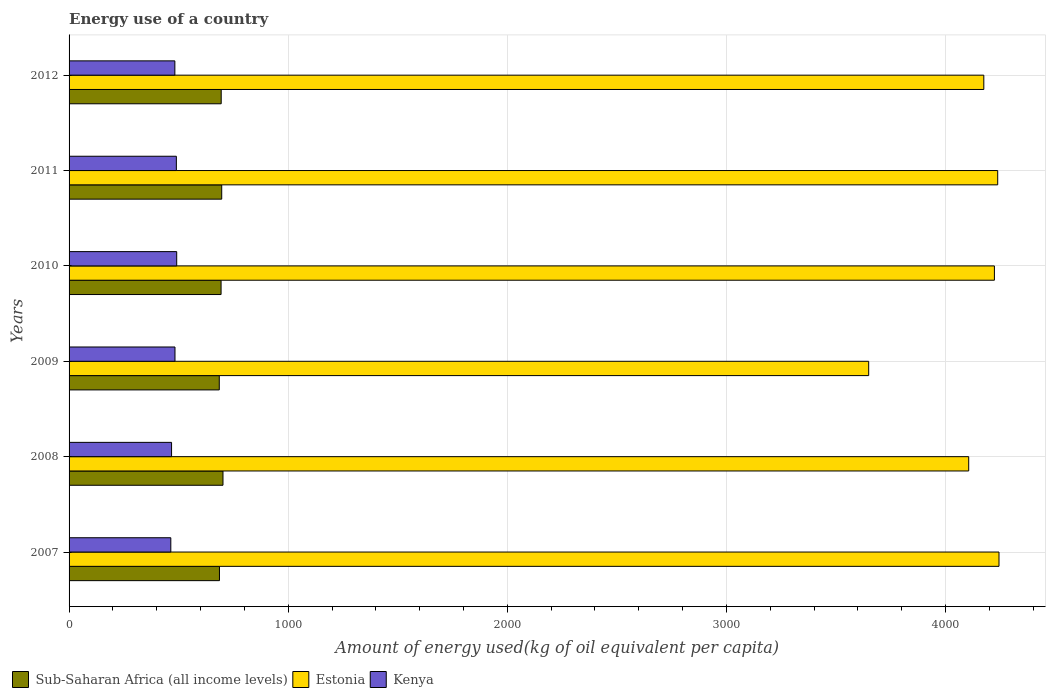How many different coloured bars are there?
Ensure brevity in your answer.  3. How many groups of bars are there?
Offer a very short reply. 6. Are the number of bars per tick equal to the number of legend labels?
Provide a succinct answer. Yes. Are the number of bars on each tick of the Y-axis equal?
Give a very brief answer. Yes. What is the amount of energy used in in Kenya in 2012?
Give a very brief answer. 482.79. Across all years, what is the maximum amount of energy used in in Estonia?
Offer a terse response. 4243.65. Across all years, what is the minimum amount of energy used in in Estonia?
Your response must be concise. 3648.98. What is the total amount of energy used in in Sub-Saharan Africa (all income levels) in the graph?
Make the answer very short. 4158.66. What is the difference between the amount of energy used in in Sub-Saharan Africa (all income levels) in 2007 and that in 2008?
Offer a terse response. -16.02. What is the difference between the amount of energy used in in Estonia in 2007 and the amount of energy used in in Sub-Saharan Africa (all income levels) in 2012?
Give a very brief answer. 3549.4. What is the average amount of energy used in in Estonia per year?
Give a very brief answer. 4105.48. In the year 2012, what is the difference between the amount of energy used in in Kenya and amount of energy used in in Estonia?
Your answer should be very brief. -3691.6. In how many years, is the amount of energy used in in Sub-Saharan Africa (all income levels) greater than 400 kg?
Your answer should be compact. 6. What is the ratio of the amount of energy used in in Kenya in 2011 to that in 2012?
Offer a very short reply. 1.01. Is the difference between the amount of energy used in in Kenya in 2007 and 2008 greater than the difference between the amount of energy used in in Estonia in 2007 and 2008?
Give a very brief answer. No. What is the difference between the highest and the second highest amount of energy used in in Estonia?
Offer a very short reply. 5.92. What is the difference between the highest and the lowest amount of energy used in in Estonia?
Your answer should be very brief. 594.67. Is the sum of the amount of energy used in in Kenya in 2008 and 2011 greater than the maximum amount of energy used in in Estonia across all years?
Provide a succinct answer. No. What does the 3rd bar from the top in 2009 represents?
Your response must be concise. Sub-Saharan Africa (all income levels). What does the 3rd bar from the bottom in 2008 represents?
Provide a succinct answer. Kenya. Is it the case that in every year, the sum of the amount of energy used in in Sub-Saharan Africa (all income levels) and amount of energy used in in Kenya is greater than the amount of energy used in in Estonia?
Your answer should be very brief. No. How many years are there in the graph?
Your answer should be compact. 6. What is the difference between two consecutive major ticks on the X-axis?
Your response must be concise. 1000. Are the values on the major ticks of X-axis written in scientific E-notation?
Give a very brief answer. No. Does the graph contain any zero values?
Provide a short and direct response. No. Does the graph contain grids?
Provide a succinct answer. Yes. How are the legend labels stacked?
Provide a short and direct response. Horizontal. What is the title of the graph?
Your answer should be compact. Energy use of a country. What is the label or title of the X-axis?
Offer a very short reply. Amount of energy used(kg of oil equivalent per capita). What is the label or title of the Y-axis?
Your answer should be very brief. Years. What is the Amount of energy used(kg of oil equivalent per capita) in Sub-Saharan Africa (all income levels) in 2007?
Offer a very short reply. 686.34. What is the Amount of energy used(kg of oil equivalent per capita) in Estonia in 2007?
Provide a succinct answer. 4243.65. What is the Amount of energy used(kg of oil equivalent per capita) in Kenya in 2007?
Keep it short and to the point. 464.27. What is the Amount of energy used(kg of oil equivalent per capita) in Sub-Saharan Africa (all income levels) in 2008?
Ensure brevity in your answer.  702.36. What is the Amount of energy used(kg of oil equivalent per capita) of Estonia in 2008?
Give a very brief answer. 4105.42. What is the Amount of energy used(kg of oil equivalent per capita) of Kenya in 2008?
Your answer should be very brief. 467.72. What is the Amount of energy used(kg of oil equivalent per capita) in Sub-Saharan Africa (all income levels) in 2009?
Give a very brief answer. 685.46. What is the Amount of energy used(kg of oil equivalent per capita) in Estonia in 2009?
Give a very brief answer. 3648.98. What is the Amount of energy used(kg of oil equivalent per capita) of Kenya in 2009?
Ensure brevity in your answer.  483.36. What is the Amount of energy used(kg of oil equivalent per capita) of Sub-Saharan Africa (all income levels) in 2010?
Offer a very short reply. 693.64. What is the Amount of energy used(kg of oil equivalent per capita) in Estonia in 2010?
Provide a succinct answer. 4222.74. What is the Amount of energy used(kg of oil equivalent per capita) of Kenya in 2010?
Provide a succinct answer. 491.17. What is the Amount of energy used(kg of oil equivalent per capita) in Sub-Saharan Africa (all income levels) in 2011?
Make the answer very short. 696.62. What is the Amount of energy used(kg of oil equivalent per capita) of Estonia in 2011?
Your response must be concise. 4237.73. What is the Amount of energy used(kg of oil equivalent per capita) in Kenya in 2011?
Ensure brevity in your answer.  489.6. What is the Amount of energy used(kg of oil equivalent per capita) of Sub-Saharan Africa (all income levels) in 2012?
Offer a very short reply. 694.25. What is the Amount of energy used(kg of oil equivalent per capita) of Estonia in 2012?
Offer a terse response. 4174.39. What is the Amount of energy used(kg of oil equivalent per capita) in Kenya in 2012?
Offer a terse response. 482.79. Across all years, what is the maximum Amount of energy used(kg of oil equivalent per capita) in Sub-Saharan Africa (all income levels)?
Ensure brevity in your answer.  702.36. Across all years, what is the maximum Amount of energy used(kg of oil equivalent per capita) of Estonia?
Give a very brief answer. 4243.65. Across all years, what is the maximum Amount of energy used(kg of oil equivalent per capita) in Kenya?
Offer a very short reply. 491.17. Across all years, what is the minimum Amount of energy used(kg of oil equivalent per capita) in Sub-Saharan Africa (all income levels)?
Provide a short and direct response. 685.46. Across all years, what is the minimum Amount of energy used(kg of oil equivalent per capita) in Estonia?
Your answer should be very brief. 3648.98. Across all years, what is the minimum Amount of energy used(kg of oil equivalent per capita) in Kenya?
Make the answer very short. 464.27. What is the total Amount of energy used(kg of oil equivalent per capita) of Sub-Saharan Africa (all income levels) in the graph?
Ensure brevity in your answer.  4158.66. What is the total Amount of energy used(kg of oil equivalent per capita) in Estonia in the graph?
Offer a very short reply. 2.46e+04. What is the total Amount of energy used(kg of oil equivalent per capita) of Kenya in the graph?
Provide a succinct answer. 2878.91. What is the difference between the Amount of energy used(kg of oil equivalent per capita) of Sub-Saharan Africa (all income levels) in 2007 and that in 2008?
Provide a short and direct response. -16.02. What is the difference between the Amount of energy used(kg of oil equivalent per capita) in Estonia in 2007 and that in 2008?
Keep it short and to the point. 138.23. What is the difference between the Amount of energy used(kg of oil equivalent per capita) of Kenya in 2007 and that in 2008?
Offer a terse response. -3.45. What is the difference between the Amount of energy used(kg of oil equivalent per capita) of Estonia in 2007 and that in 2009?
Provide a succinct answer. 594.67. What is the difference between the Amount of energy used(kg of oil equivalent per capita) of Kenya in 2007 and that in 2009?
Give a very brief answer. -19.09. What is the difference between the Amount of energy used(kg of oil equivalent per capita) in Sub-Saharan Africa (all income levels) in 2007 and that in 2010?
Your response must be concise. -7.31. What is the difference between the Amount of energy used(kg of oil equivalent per capita) in Estonia in 2007 and that in 2010?
Ensure brevity in your answer.  20.91. What is the difference between the Amount of energy used(kg of oil equivalent per capita) of Kenya in 2007 and that in 2010?
Give a very brief answer. -26.9. What is the difference between the Amount of energy used(kg of oil equivalent per capita) in Sub-Saharan Africa (all income levels) in 2007 and that in 2011?
Offer a very short reply. -10.29. What is the difference between the Amount of energy used(kg of oil equivalent per capita) of Estonia in 2007 and that in 2011?
Offer a terse response. 5.92. What is the difference between the Amount of energy used(kg of oil equivalent per capita) of Kenya in 2007 and that in 2011?
Ensure brevity in your answer.  -25.33. What is the difference between the Amount of energy used(kg of oil equivalent per capita) of Sub-Saharan Africa (all income levels) in 2007 and that in 2012?
Provide a succinct answer. -7.91. What is the difference between the Amount of energy used(kg of oil equivalent per capita) of Estonia in 2007 and that in 2012?
Keep it short and to the point. 69.26. What is the difference between the Amount of energy used(kg of oil equivalent per capita) of Kenya in 2007 and that in 2012?
Offer a terse response. -18.52. What is the difference between the Amount of energy used(kg of oil equivalent per capita) in Sub-Saharan Africa (all income levels) in 2008 and that in 2009?
Keep it short and to the point. 16.9. What is the difference between the Amount of energy used(kg of oil equivalent per capita) of Estonia in 2008 and that in 2009?
Give a very brief answer. 456.44. What is the difference between the Amount of energy used(kg of oil equivalent per capita) in Kenya in 2008 and that in 2009?
Provide a short and direct response. -15.65. What is the difference between the Amount of energy used(kg of oil equivalent per capita) in Sub-Saharan Africa (all income levels) in 2008 and that in 2010?
Make the answer very short. 8.71. What is the difference between the Amount of energy used(kg of oil equivalent per capita) of Estonia in 2008 and that in 2010?
Make the answer very short. -117.32. What is the difference between the Amount of energy used(kg of oil equivalent per capita) in Kenya in 2008 and that in 2010?
Provide a succinct answer. -23.45. What is the difference between the Amount of energy used(kg of oil equivalent per capita) of Sub-Saharan Africa (all income levels) in 2008 and that in 2011?
Make the answer very short. 5.74. What is the difference between the Amount of energy used(kg of oil equivalent per capita) of Estonia in 2008 and that in 2011?
Your answer should be very brief. -132.31. What is the difference between the Amount of energy used(kg of oil equivalent per capita) in Kenya in 2008 and that in 2011?
Ensure brevity in your answer.  -21.88. What is the difference between the Amount of energy used(kg of oil equivalent per capita) of Sub-Saharan Africa (all income levels) in 2008 and that in 2012?
Ensure brevity in your answer.  8.11. What is the difference between the Amount of energy used(kg of oil equivalent per capita) in Estonia in 2008 and that in 2012?
Provide a short and direct response. -68.97. What is the difference between the Amount of energy used(kg of oil equivalent per capita) of Kenya in 2008 and that in 2012?
Ensure brevity in your answer.  -15.07. What is the difference between the Amount of energy used(kg of oil equivalent per capita) in Sub-Saharan Africa (all income levels) in 2009 and that in 2010?
Keep it short and to the point. -8.19. What is the difference between the Amount of energy used(kg of oil equivalent per capita) in Estonia in 2009 and that in 2010?
Provide a succinct answer. -573.76. What is the difference between the Amount of energy used(kg of oil equivalent per capita) of Kenya in 2009 and that in 2010?
Your answer should be compact. -7.81. What is the difference between the Amount of energy used(kg of oil equivalent per capita) of Sub-Saharan Africa (all income levels) in 2009 and that in 2011?
Keep it short and to the point. -11.17. What is the difference between the Amount of energy used(kg of oil equivalent per capita) of Estonia in 2009 and that in 2011?
Provide a short and direct response. -588.75. What is the difference between the Amount of energy used(kg of oil equivalent per capita) in Kenya in 2009 and that in 2011?
Provide a succinct answer. -6.23. What is the difference between the Amount of energy used(kg of oil equivalent per capita) in Sub-Saharan Africa (all income levels) in 2009 and that in 2012?
Make the answer very short. -8.79. What is the difference between the Amount of energy used(kg of oil equivalent per capita) in Estonia in 2009 and that in 2012?
Provide a succinct answer. -525.41. What is the difference between the Amount of energy used(kg of oil equivalent per capita) of Kenya in 2009 and that in 2012?
Offer a terse response. 0.58. What is the difference between the Amount of energy used(kg of oil equivalent per capita) in Sub-Saharan Africa (all income levels) in 2010 and that in 2011?
Your answer should be very brief. -2.98. What is the difference between the Amount of energy used(kg of oil equivalent per capita) of Estonia in 2010 and that in 2011?
Your answer should be very brief. -14.99. What is the difference between the Amount of energy used(kg of oil equivalent per capita) in Kenya in 2010 and that in 2011?
Provide a short and direct response. 1.57. What is the difference between the Amount of energy used(kg of oil equivalent per capita) of Sub-Saharan Africa (all income levels) in 2010 and that in 2012?
Ensure brevity in your answer.  -0.6. What is the difference between the Amount of energy used(kg of oil equivalent per capita) of Estonia in 2010 and that in 2012?
Your response must be concise. 48.35. What is the difference between the Amount of energy used(kg of oil equivalent per capita) in Kenya in 2010 and that in 2012?
Your answer should be compact. 8.38. What is the difference between the Amount of energy used(kg of oil equivalent per capita) of Sub-Saharan Africa (all income levels) in 2011 and that in 2012?
Ensure brevity in your answer.  2.38. What is the difference between the Amount of energy used(kg of oil equivalent per capita) in Estonia in 2011 and that in 2012?
Ensure brevity in your answer.  63.34. What is the difference between the Amount of energy used(kg of oil equivalent per capita) of Kenya in 2011 and that in 2012?
Offer a terse response. 6.81. What is the difference between the Amount of energy used(kg of oil equivalent per capita) of Sub-Saharan Africa (all income levels) in 2007 and the Amount of energy used(kg of oil equivalent per capita) of Estonia in 2008?
Offer a very short reply. -3419.08. What is the difference between the Amount of energy used(kg of oil equivalent per capita) of Sub-Saharan Africa (all income levels) in 2007 and the Amount of energy used(kg of oil equivalent per capita) of Kenya in 2008?
Give a very brief answer. 218.62. What is the difference between the Amount of energy used(kg of oil equivalent per capita) in Estonia in 2007 and the Amount of energy used(kg of oil equivalent per capita) in Kenya in 2008?
Your answer should be very brief. 3775.93. What is the difference between the Amount of energy used(kg of oil equivalent per capita) of Sub-Saharan Africa (all income levels) in 2007 and the Amount of energy used(kg of oil equivalent per capita) of Estonia in 2009?
Provide a short and direct response. -2962.64. What is the difference between the Amount of energy used(kg of oil equivalent per capita) of Sub-Saharan Africa (all income levels) in 2007 and the Amount of energy used(kg of oil equivalent per capita) of Kenya in 2009?
Offer a terse response. 202.97. What is the difference between the Amount of energy used(kg of oil equivalent per capita) of Estonia in 2007 and the Amount of energy used(kg of oil equivalent per capita) of Kenya in 2009?
Keep it short and to the point. 3760.28. What is the difference between the Amount of energy used(kg of oil equivalent per capita) in Sub-Saharan Africa (all income levels) in 2007 and the Amount of energy used(kg of oil equivalent per capita) in Estonia in 2010?
Ensure brevity in your answer.  -3536.4. What is the difference between the Amount of energy used(kg of oil equivalent per capita) in Sub-Saharan Africa (all income levels) in 2007 and the Amount of energy used(kg of oil equivalent per capita) in Kenya in 2010?
Your answer should be very brief. 195.16. What is the difference between the Amount of energy used(kg of oil equivalent per capita) of Estonia in 2007 and the Amount of energy used(kg of oil equivalent per capita) of Kenya in 2010?
Your answer should be compact. 3752.48. What is the difference between the Amount of energy used(kg of oil equivalent per capita) in Sub-Saharan Africa (all income levels) in 2007 and the Amount of energy used(kg of oil equivalent per capita) in Estonia in 2011?
Your response must be concise. -3551.39. What is the difference between the Amount of energy used(kg of oil equivalent per capita) in Sub-Saharan Africa (all income levels) in 2007 and the Amount of energy used(kg of oil equivalent per capita) in Kenya in 2011?
Provide a short and direct response. 196.74. What is the difference between the Amount of energy used(kg of oil equivalent per capita) of Estonia in 2007 and the Amount of energy used(kg of oil equivalent per capita) of Kenya in 2011?
Your response must be concise. 3754.05. What is the difference between the Amount of energy used(kg of oil equivalent per capita) in Sub-Saharan Africa (all income levels) in 2007 and the Amount of energy used(kg of oil equivalent per capita) in Estonia in 2012?
Provide a succinct answer. -3488.05. What is the difference between the Amount of energy used(kg of oil equivalent per capita) of Sub-Saharan Africa (all income levels) in 2007 and the Amount of energy used(kg of oil equivalent per capita) of Kenya in 2012?
Offer a terse response. 203.55. What is the difference between the Amount of energy used(kg of oil equivalent per capita) in Estonia in 2007 and the Amount of energy used(kg of oil equivalent per capita) in Kenya in 2012?
Provide a short and direct response. 3760.86. What is the difference between the Amount of energy used(kg of oil equivalent per capita) in Sub-Saharan Africa (all income levels) in 2008 and the Amount of energy used(kg of oil equivalent per capita) in Estonia in 2009?
Your answer should be very brief. -2946.62. What is the difference between the Amount of energy used(kg of oil equivalent per capita) of Sub-Saharan Africa (all income levels) in 2008 and the Amount of energy used(kg of oil equivalent per capita) of Kenya in 2009?
Offer a very short reply. 218.99. What is the difference between the Amount of energy used(kg of oil equivalent per capita) of Estonia in 2008 and the Amount of energy used(kg of oil equivalent per capita) of Kenya in 2009?
Provide a short and direct response. 3622.05. What is the difference between the Amount of energy used(kg of oil equivalent per capita) in Sub-Saharan Africa (all income levels) in 2008 and the Amount of energy used(kg of oil equivalent per capita) in Estonia in 2010?
Provide a succinct answer. -3520.38. What is the difference between the Amount of energy used(kg of oil equivalent per capita) in Sub-Saharan Africa (all income levels) in 2008 and the Amount of energy used(kg of oil equivalent per capita) in Kenya in 2010?
Keep it short and to the point. 211.19. What is the difference between the Amount of energy used(kg of oil equivalent per capita) in Estonia in 2008 and the Amount of energy used(kg of oil equivalent per capita) in Kenya in 2010?
Offer a very short reply. 3614.25. What is the difference between the Amount of energy used(kg of oil equivalent per capita) of Sub-Saharan Africa (all income levels) in 2008 and the Amount of energy used(kg of oil equivalent per capita) of Estonia in 2011?
Offer a very short reply. -3535.37. What is the difference between the Amount of energy used(kg of oil equivalent per capita) in Sub-Saharan Africa (all income levels) in 2008 and the Amount of energy used(kg of oil equivalent per capita) in Kenya in 2011?
Give a very brief answer. 212.76. What is the difference between the Amount of energy used(kg of oil equivalent per capita) in Estonia in 2008 and the Amount of energy used(kg of oil equivalent per capita) in Kenya in 2011?
Provide a succinct answer. 3615.82. What is the difference between the Amount of energy used(kg of oil equivalent per capita) in Sub-Saharan Africa (all income levels) in 2008 and the Amount of energy used(kg of oil equivalent per capita) in Estonia in 2012?
Ensure brevity in your answer.  -3472.03. What is the difference between the Amount of energy used(kg of oil equivalent per capita) of Sub-Saharan Africa (all income levels) in 2008 and the Amount of energy used(kg of oil equivalent per capita) of Kenya in 2012?
Provide a succinct answer. 219.57. What is the difference between the Amount of energy used(kg of oil equivalent per capita) in Estonia in 2008 and the Amount of energy used(kg of oil equivalent per capita) in Kenya in 2012?
Ensure brevity in your answer.  3622.63. What is the difference between the Amount of energy used(kg of oil equivalent per capita) of Sub-Saharan Africa (all income levels) in 2009 and the Amount of energy used(kg of oil equivalent per capita) of Estonia in 2010?
Offer a terse response. -3537.28. What is the difference between the Amount of energy used(kg of oil equivalent per capita) of Sub-Saharan Africa (all income levels) in 2009 and the Amount of energy used(kg of oil equivalent per capita) of Kenya in 2010?
Your answer should be very brief. 194.28. What is the difference between the Amount of energy used(kg of oil equivalent per capita) in Estonia in 2009 and the Amount of energy used(kg of oil equivalent per capita) in Kenya in 2010?
Provide a short and direct response. 3157.81. What is the difference between the Amount of energy used(kg of oil equivalent per capita) of Sub-Saharan Africa (all income levels) in 2009 and the Amount of energy used(kg of oil equivalent per capita) of Estonia in 2011?
Offer a terse response. -3552.27. What is the difference between the Amount of energy used(kg of oil equivalent per capita) in Sub-Saharan Africa (all income levels) in 2009 and the Amount of energy used(kg of oil equivalent per capita) in Kenya in 2011?
Provide a succinct answer. 195.86. What is the difference between the Amount of energy used(kg of oil equivalent per capita) of Estonia in 2009 and the Amount of energy used(kg of oil equivalent per capita) of Kenya in 2011?
Your answer should be very brief. 3159.38. What is the difference between the Amount of energy used(kg of oil equivalent per capita) in Sub-Saharan Africa (all income levels) in 2009 and the Amount of energy used(kg of oil equivalent per capita) in Estonia in 2012?
Provide a short and direct response. -3488.93. What is the difference between the Amount of energy used(kg of oil equivalent per capita) in Sub-Saharan Africa (all income levels) in 2009 and the Amount of energy used(kg of oil equivalent per capita) in Kenya in 2012?
Ensure brevity in your answer.  202.67. What is the difference between the Amount of energy used(kg of oil equivalent per capita) of Estonia in 2009 and the Amount of energy used(kg of oil equivalent per capita) of Kenya in 2012?
Provide a succinct answer. 3166.19. What is the difference between the Amount of energy used(kg of oil equivalent per capita) in Sub-Saharan Africa (all income levels) in 2010 and the Amount of energy used(kg of oil equivalent per capita) in Estonia in 2011?
Provide a succinct answer. -3544.09. What is the difference between the Amount of energy used(kg of oil equivalent per capita) in Sub-Saharan Africa (all income levels) in 2010 and the Amount of energy used(kg of oil equivalent per capita) in Kenya in 2011?
Offer a very short reply. 204.05. What is the difference between the Amount of energy used(kg of oil equivalent per capita) in Estonia in 2010 and the Amount of energy used(kg of oil equivalent per capita) in Kenya in 2011?
Your answer should be very brief. 3733.14. What is the difference between the Amount of energy used(kg of oil equivalent per capita) in Sub-Saharan Africa (all income levels) in 2010 and the Amount of energy used(kg of oil equivalent per capita) in Estonia in 2012?
Give a very brief answer. -3480.74. What is the difference between the Amount of energy used(kg of oil equivalent per capita) of Sub-Saharan Africa (all income levels) in 2010 and the Amount of energy used(kg of oil equivalent per capita) of Kenya in 2012?
Offer a very short reply. 210.86. What is the difference between the Amount of energy used(kg of oil equivalent per capita) in Estonia in 2010 and the Amount of energy used(kg of oil equivalent per capita) in Kenya in 2012?
Your response must be concise. 3739.95. What is the difference between the Amount of energy used(kg of oil equivalent per capita) in Sub-Saharan Africa (all income levels) in 2011 and the Amount of energy used(kg of oil equivalent per capita) in Estonia in 2012?
Provide a succinct answer. -3477.77. What is the difference between the Amount of energy used(kg of oil equivalent per capita) of Sub-Saharan Africa (all income levels) in 2011 and the Amount of energy used(kg of oil equivalent per capita) of Kenya in 2012?
Your answer should be very brief. 213.84. What is the difference between the Amount of energy used(kg of oil equivalent per capita) of Estonia in 2011 and the Amount of energy used(kg of oil equivalent per capita) of Kenya in 2012?
Provide a short and direct response. 3754.94. What is the average Amount of energy used(kg of oil equivalent per capita) of Sub-Saharan Africa (all income levels) per year?
Provide a succinct answer. 693.11. What is the average Amount of energy used(kg of oil equivalent per capita) in Estonia per year?
Ensure brevity in your answer.  4105.48. What is the average Amount of energy used(kg of oil equivalent per capita) of Kenya per year?
Your response must be concise. 479.82. In the year 2007, what is the difference between the Amount of energy used(kg of oil equivalent per capita) of Sub-Saharan Africa (all income levels) and Amount of energy used(kg of oil equivalent per capita) of Estonia?
Give a very brief answer. -3557.31. In the year 2007, what is the difference between the Amount of energy used(kg of oil equivalent per capita) in Sub-Saharan Africa (all income levels) and Amount of energy used(kg of oil equivalent per capita) in Kenya?
Your answer should be compact. 222.07. In the year 2007, what is the difference between the Amount of energy used(kg of oil equivalent per capita) in Estonia and Amount of energy used(kg of oil equivalent per capita) in Kenya?
Ensure brevity in your answer.  3779.38. In the year 2008, what is the difference between the Amount of energy used(kg of oil equivalent per capita) of Sub-Saharan Africa (all income levels) and Amount of energy used(kg of oil equivalent per capita) of Estonia?
Offer a very short reply. -3403.06. In the year 2008, what is the difference between the Amount of energy used(kg of oil equivalent per capita) in Sub-Saharan Africa (all income levels) and Amount of energy used(kg of oil equivalent per capita) in Kenya?
Offer a very short reply. 234.64. In the year 2008, what is the difference between the Amount of energy used(kg of oil equivalent per capita) in Estonia and Amount of energy used(kg of oil equivalent per capita) in Kenya?
Provide a short and direct response. 3637.7. In the year 2009, what is the difference between the Amount of energy used(kg of oil equivalent per capita) of Sub-Saharan Africa (all income levels) and Amount of energy used(kg of oil equivalent per capita) of Estonia?
Ensure brevity in your answer.  -2963.52. In the year 2009, what is the difference between the Amount of energy used(kg of oil equivalent per capita) of Sub-Saharan Africa (all income levels) and Amount of energy used(kg of oil equivalent per capita) of Kenya?
Your answer should be very brief. 202.09. In the year 2009, what is the difference between the Amount of energy used(kg of oil equivalent per capita) in Estonia and Amount of energy used(kg of oil equivalent per capita) in Kenya?
Ensure brevity in your answer.  3165.62. In the year 2010, what is the difference between the Amount of energy used(kg of oil equivalent per capita) in Sub-Saharan Africa (all income levels) and Amount of energy used(kg of oil equivalent per capita) in Estonia?
Provide a short and direct response. -3529.09. In the year 2010, what is the difference between the Amount of energy used(kg of oil equivalent per capita) of Sub-Saharan Africa (all income levels) and Amount of energy used(kg of oil equivalent per capita) of Kenya?
Offer a terse response. 202.47. In the year 2010, what is the difference between the Amount of energy used(kg of oil equivalent per capita) of Estonia and Amount of energy used(kg of oil equivalent per capita) of Kenya?
Keep it short and to the point. 3731.57. In the year 2011, what is the difference between the Amount of energy used(kg of oil equivalent per capita) in Sub-Saharan Africa (all income levels) and Amount of energy used(kg of oil equivalent per capita) in Estonia?
Your answer should be very brief. -3541.11. In the year 2011, what is the difference between the Amount of energy used(kg of oil equivalent per capita) of Sub-Saharan Africa (all income levels) and Amount of energy used(kg of oil equivalent per capita) of Kenya?
Ensure brevity in your answer.  207.02. In the year 2011, what is the difference between the Amount of energy used(kg of oil equivalent per capita) of Estonia and Amount of energy used(kg of oil equivalent per capita) of Kenya?
Keep it short and to the point. 3748.13. In the year 2012, what is the difference between the Amount of energy used(kg of oil equivalent per capita) of Sub-Saharan Africa (all income levels) and Amount of energy used(kg of oil equivalent per capita) of Estonia?
Give a very brief answer. -3480.14. In the year 2012, what is the difference between the Amount of energy used(kg of oil equivalent per capita) in Sub-Saharan Africa (all income levels) and Amount of energy used(kg of oil equivalent per capita) in Kenya?
Provide a short and direct response. 211.46. In the year 2012, what is the difference between the Amount of energy used(kg of oil equivalent per capita) of Estonia and Amount of energy used(kg of oil equivalent per capita) of Kenya?
Make the answer very short. 3691.6. What is the ratio of the Amount of energy used(kg of oil equivalent per capita) in Sub-Saharan Africa (all income levels) in 2007 to that in 2008?
Make the answer very short. 0.98. What is the ratio of the Amount of energy used(kg of oil equivalent per capita) in Estonia in 2007 to that in 2008?
Offer a very short reply. 1.03. What is the ratio of the Amount of energy used(kg of oil equivalent per capita) in Kenya in 2007 to that in 2008?
Ensure brevity in your answer.  0.99. What is the ratio of the Amount of energy used(kg of oil equivalent per capita) of Estonia in 2007 to that in 2009?
Provide a short and direct response. 1.16. What is the ratio of the Amount of energy used(kg of oil equivalent per capita) of Kenya in 2007 to that in 2009?
Offer a terse response. 0.96. What is the ratio of the Amount of energy used(kg of oil equivalent per capita) in Kenya in 2007 to that in 2010?
Your answer should be compact. 0.95. What is the ratio of the Amount of energy used(kg of oil equivalent per capita) in Sub-Saharan Africa (all income levels) in 2007 to that in 2011?
Offer a terse response. 0.99. What is the ratio of the Amount of energy used(kg of oil equivalent per capita) in Kenya in 2007 to that in 2011?
Your answer should be very brief. 0.95. What is the ratio of the Amount of energy used(kg of oil equivalent per capita) of Sub-Saharan Africa (all income levels) in 2007 to that in 2012?
Your answer should be very brief. 0.99. What is the ratio of the Amount of energy used(kg of oil equivalent per capita) in Estonia in 2007 to that in 2012?
Ensure brevity in your answer.  1.02. What is the ratio of the Amount of energy used(kg of oil equivalent per capita) in Kenya in 2007 to that in 2012?
Your answer should be very brief. 0.96. What is the ratio of the Amount of energy used(kg of oil equivalent per capita) of Sub-Saharan Africa (all income levels) in 2008 to that in 2009?
Your answer should be very brief. 1.02. What is the ratio of the Amount of energy used(kg of oil equivalent per capita) of Estonia in 2008 to that in 2009?
Offer a very short reply. 1.13. What is the ratio of the Amount of energy used(kg of oil equivalent per capita) in Kenya in 2008 to that in 2009?
Provide a succinct answer. 0.97. What is the ratio of the Amount of energy used(kg of oil equivalent per capita) of Sub-Saharan Africa (all income levels) in 2008 to that in 2010?
Offer a terse response. 1.01. What is the ratio of the Amount of energy used(kg of oil equivalent per capita) of Estonia in 2008 to that in 2010?
Offer a terse response. 0.97. What is the ratio of the Amount of energy used(kg of oil equivalent per capita) in Kenya in 2008 to that in 2010?
Offer a terse response. 0.95. What is the ratio of the Amount of energy used(kg of oil equivalent per capita) in Sub-Saharan Africa (all income levels) in 2008 to that in 2011?
Offer a very short reply. 1.01. What is the ratio of the Amount of energy used(kg of oil equivalent per capita) in Estonia in 2008 to that in 2011?
Provide a short and direct response. 0.97. What is the ratio of the Amount of energy used(kg of oil equivalent per capita) in Kenya in 2008 to that in 2011?
Give a very brief answer. 0.96. What is the ratio of the Amount of energy used(kg of oil equivalent per capita) of Sub-Saharan Africa (all income levels) in 2008 to that in 2012?
Make the answer very short. 1.01. What is the ratio of the Amount of energy used(kg of oil equivalent per capita) of Estonia in 2008 to that in 2012?
Offer a very short reply. 0.98. What is the ratio of the Amount of energy used(kg of oil equivalent per capita) in Kenya in 2008 to that in 2012?
Your answer should be compact. 0.97. What is the ratio of the Amount of energy used(kg of oil equivalent per capita) of Sub-Saharan Africa (all income levels) in 2009 to that in 2010?
Your answer should be very brief. 0.99. What is the ratio of the Amount of energy used(kg of oil equivalent per capita) of Estonia in 2009 to that in 2010?
Ensure brevity in your answer.  0.86. What is the ratio of the Amount of energy used(kg of oil equivalent per capita) in Kenya in 2009 to that in 2010?
Offer a very short reply. 0.98. What is the ratio of the Amount of energy used(kg of oil equivalent per capita) in Estonia in 2009 to that in 2011?
Ensure brevity in your answer.  0.86. What is the ratio of the Amount of energy used(kg of oil equivalent per capita) in Kenya in 2009 to that in 2011?
Keep it short and to the point. 0.99. What is the ratio of the Amount of energy used(kg of oil equivalent per capita) in Sub-Saharan Africa (all income levels) in 2009 to that in 2012?
Your answer should be compact. 0.99. What is the ratio of the Amount of energy used(kg of oil equivalent per capita) in Estonia in 2009 to that in 2012?
Offer a terse response. 0.87. What is the ratio of the Amount of energy used(kg of oil equivalent per capita) in Kenya in 2009 to that in 2012?
Provide a succinct answer. 1. What is the ratio of the Amount of energy used(kg of oil equivalent per capita) in Estonia in 2010 to that in 2011?
Your answer should be very brief. 1. What is the ratio of the Amount of energy used(kg of oil equivalent per capita) of Kenya in 2010 to that in 2011?
Offer a terse response. 1. What is the ratio of the Amount of energy used(kg of oil equivalent per capita) of Sub-Saharan Africa (all income levels) in 2010 to that in 2012?
Your answer should be very brief. 1. What is the ratio of the Amount of energy used(kg of oil equivalent per capita) in Estonia in 2010 to that in 2012?
Offer a terse response. 1.01. What is the ratio of the Amount of energy used(kg of oil equivalent per capita) in Kenya in 2010 to that in 2012?
Give a very brief answer. 1.02. What is the ratio of the Amount of energy used(kg of oil equivalent per capita) of Sub-Saharan Africa (all income levels) in 2011 to that in 2012?
Offer a terse response. 1. What is the ratio of the Amount of energy used(kg of oil equivalent per capita) in Estonia in 2011 to that in 2012?
Your answer should be compact. 1.02. What is the ratio of the Amount of energy used(kg of oil equivalent per capita) of Kenya in 2011 to that in 2012?
Ensure brevity in your answer.  1.01. What is the difference between the highest and the second highest Amount of energy used(kg of oil equivalent per capita) in Sub-Saharan Africa (all income levels)?
Provide a succinct answer. 5.74. What is the difference between the highest and the second highest Amount of energy used(kg of oil equivalent per capita) of Estonia?
Your response must be concise. 5.92. What is the difference between the highest and the second highest Amount of energy used(kg of oil equivalent per capita) of Kenya?
Make the answer very short. 1.57. What is the difference between the highest and the lowest Amount of energy used(kg of oil equivalent per capita) of Sub-Saharan Africa (all income levels)?
Provide a short and direct response. 16.9. What is the difference between the highest and the lowest Amount of energy used(kg of oil equivalent per capita) of Estonia?
Ensure brevity in your answer.  594.67. What is the difference between the highest and the lowest Amount of energy used(kg of oil equivalent per capita) of Kenya?
Your answer should be very brief. 26.9. 